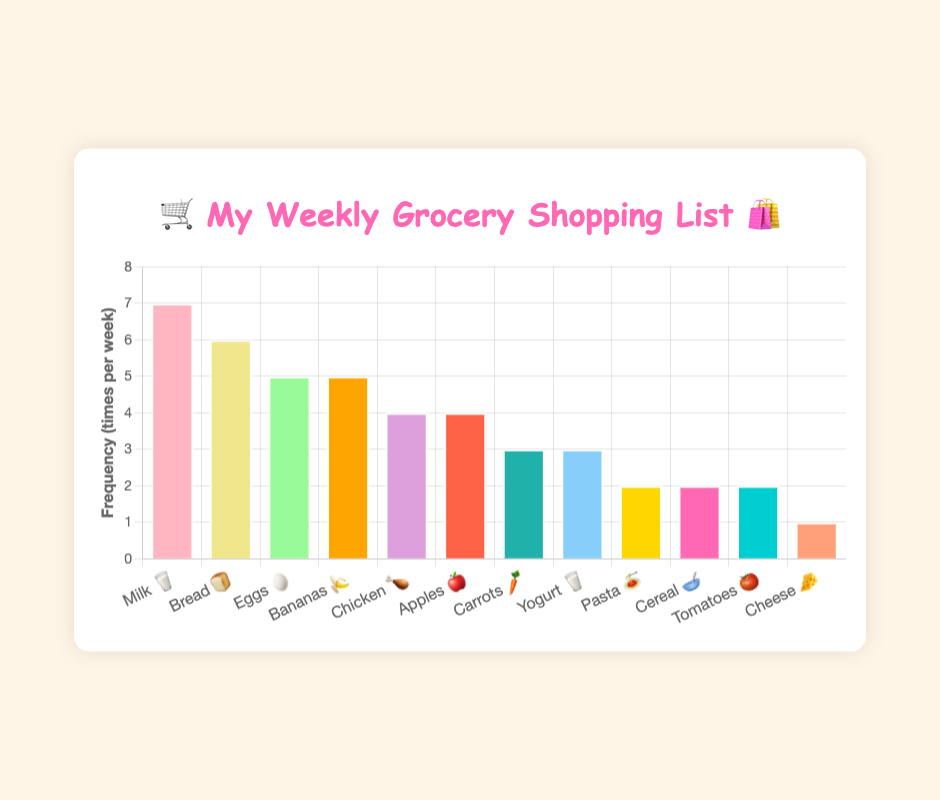How many items are listed on the chart? Count each unique item listed on the x-axis to find the total number. There are 12 items in total, ranging from Milk 🥛 to Cheese 🧀.
Answer: 12 What is the title of the chart? Look at the top center portion of the chart to find the title text. The title is "🛒 My Weekly Grocery Shopping List 🛍️".
Answer: 🛒 My Weekly Grocery Shopping List 🛍️ Which item is bought most frequently? Identify the bar with the highest value on the y-axis, which corresponds to the item on the x-axis. The tallest bar corresponds to Milk 🥛 at a frequency of 7.
Answer: Milk 🥛 What is the frequency of the least bought item? Find the shortest bar on the y-axis to determine the frequency. The shortest bar corresponds to Cheese 🧀 with a frequency of 1.
Answer: 1 Are eggs bought more frequently than apples? Compare the height of the bars for Eggs 🥚 and Apples 🍎. Eggs 🥚 have a frequency of 5 while Apples 🍎 have a frequency of 4.
Answer: Yes How many items are bought more than 4 times a week? Count the number of items with bars having a height greater than 4. Milk 🥛, Bread 🍞, Eggs 🥚, and Bananas 🍌 are bought more than 4 times, totaling 4 items.
Answer: 4 What is the total frequency of all items combined? Sum the frequencies of all items: 7 + 6 + 5 + 5 + 4 + 4 + 3 + 3 + 2 + 2 + 2 + 1 = 44.
Answer: 44 Which two items have the same buying frequency of 5? Identify the bars with the frequency of 5 on the y-axis. Eggs 🥚 and Bananas 🍌 both have a frequency of 5.
Answer: Eggs 🥚 and Bananas 🍌 What is the difference in frequency between the most and least bought items? Subtract the frequency of Cheese 🧀 (least bought) from Milk 🥛 (most bought). 7 - 1 = 6.
Answer: 6 How often is chicken bought compared to yogurt? Compare the bars for Chicken 🍗 and Yogurt 🥛 on the y-axis. Chicken 🍗 has a frequency of 4 and Yogurt 🥛 has a frequency of 3.
Answer: More 